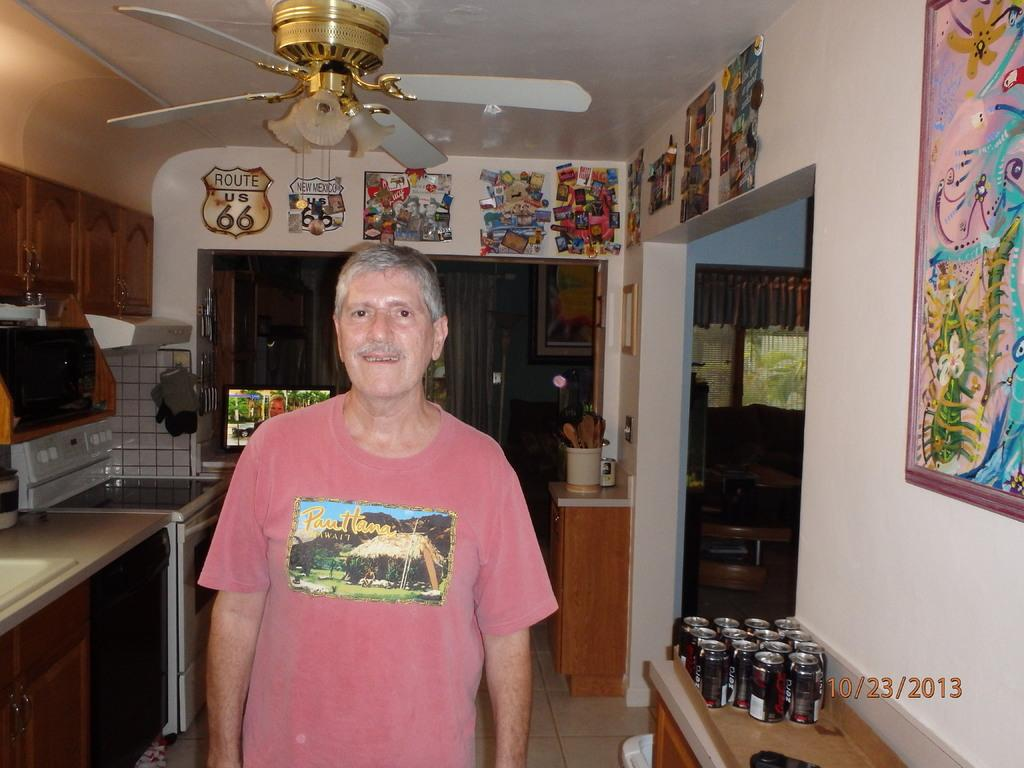What is one of the structures visible in the image? There is a wall in the image. What object is used for displaying photos in the image? There is a photo frame in the image. What type of item can be seen on the wall in the image? There is a paper in the image. What is the man standing in front of in the image? The man is standing in front of a can in the image. What appliance is present in the image? There is a washing machine in the image. What type of gas is visible in the image? There is a gas in the image. What piece of furniture is present in the image? There is a table in the image. What type of items are on the table in the image? There are tins on the table in the image. What type of pen is the man using to write on the wall in the image? There is no pen visible in the image, and the man is not writing on the wall. What type of van is parked in front of the house in the image? There is no van present in the image. 